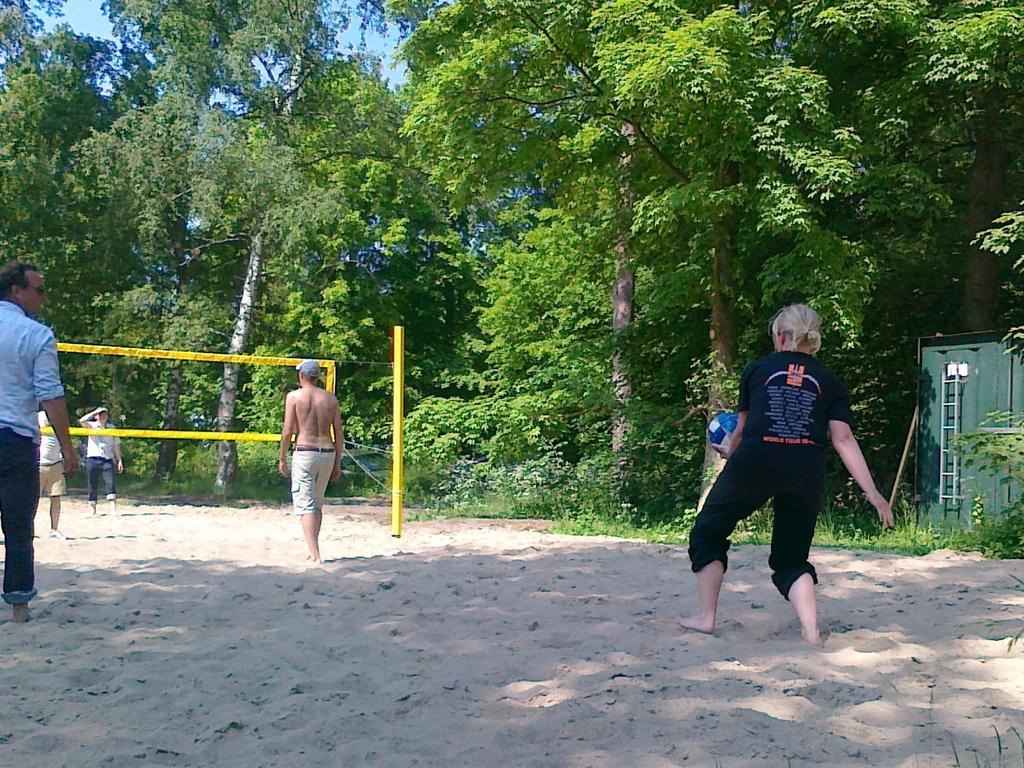How would you summarize this image in a sentence or two? On the left side, there is a person in blue color shirt standing on the sand surface. On the right side, there is a person in black color dress holding a ball with one hand and standing on the sand surface. In the background, there are persons standing on the sand surface, there is an yellow color net attached to the yellow color pole, there are trees and there is blue sky. 